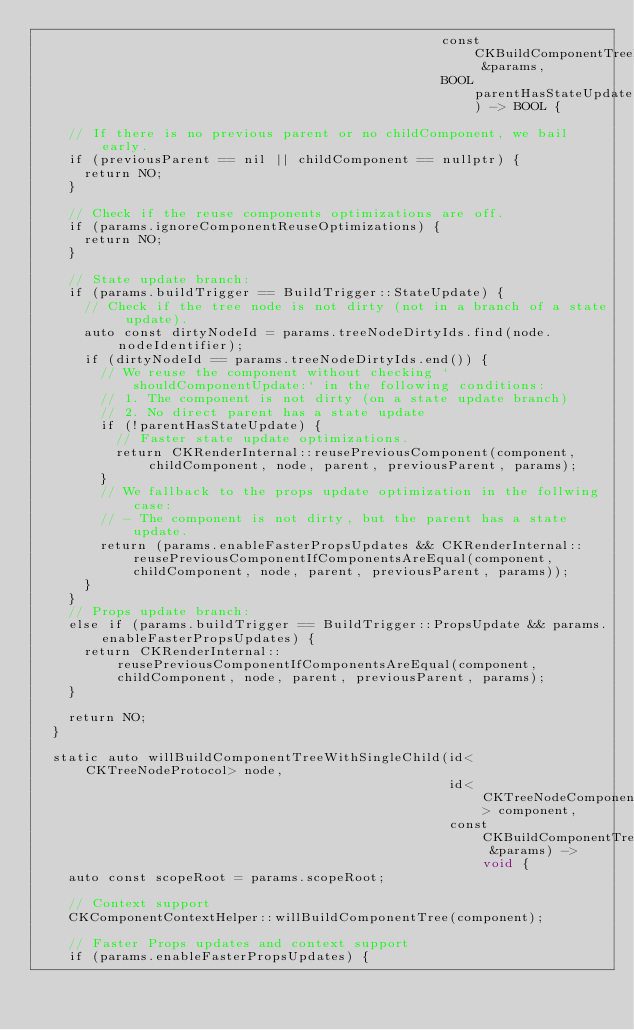Convert code to text. <code><loc_0><loc_0><loc_500><loc_500><_ObjectiveC_>                                                   const CKBuildComponentTreeParams &params,
                                                   BOOL parentHasStateUpdate) -> BOOL {

    // If there is no previous parent or no childComponent, we bail early.
    if (previousParent == nil || childComponent == nullptr) {
      return NO;
    }

    // Check if the reuse components optimizations are off.
    if (params.ignoreComponentReuseOptimizations) {
      return NO;
    }

    // State update branch:
    if (params.buildTrigger == BuildTrigger::StateUpdate) {
      // Check if the tree node is not dirty (not in a branch of a state update).
      auto const dirtyNodeId = params.treeNodeDirtyIds.find(node.nodeIdentifier);
      if (dirtyNodeId == params.treeNodeDirtyIds.end()) {
        // We reuse the component without checking `shouldComponentUpdate:` in the following conditions:
        // 1. The component is not dirty (on a state update branch)
        // 2. No direct parent has a state update
        if (!parentHasStateUpdate) {
          // Faster state update optimizations.
          return CKRenderInternal::reusePreviousComponent(component, childComponent, node, parent, previousParent, params);
        }
        // We fallback to the props update optimization in the follwing case:
        // - The component is not dirty, but the parent has a state update.
        return (params.enableFasterPropsUpdates && CKRenderInternal::reusePreviousComponentIfComponentsAreEqual(component, childComponent, node, parent, previousParent, params));
      }
    }
    // Props update branch:
    else if (params.buildTrigger == BuildTrigger::PropsUpdate && params.enableFasterPropsUpdates) {
      return CKRenderInternal::reusePreviousComponentIfComponentsAreEqual(component, childComponent, node, parent, previousParent, params);
    }

    return NO;
  }

  static auto willBuildComponentTreeWithSingleChild(id<CKTreeNodeProtocol> node,
                                                    id<CKTreeNodeComponentProtocol> component,
                                                    const CKBuildComponentTreeParams &params) -> void {
    auto const scopeRoot = params.scopeRoot;

    // Context support
    CKComponentContextHelper::willBuildComponentTree(component);

    // Faster Props updates and context support
    if (params.enableFasterPropsUpdates) {</code> 